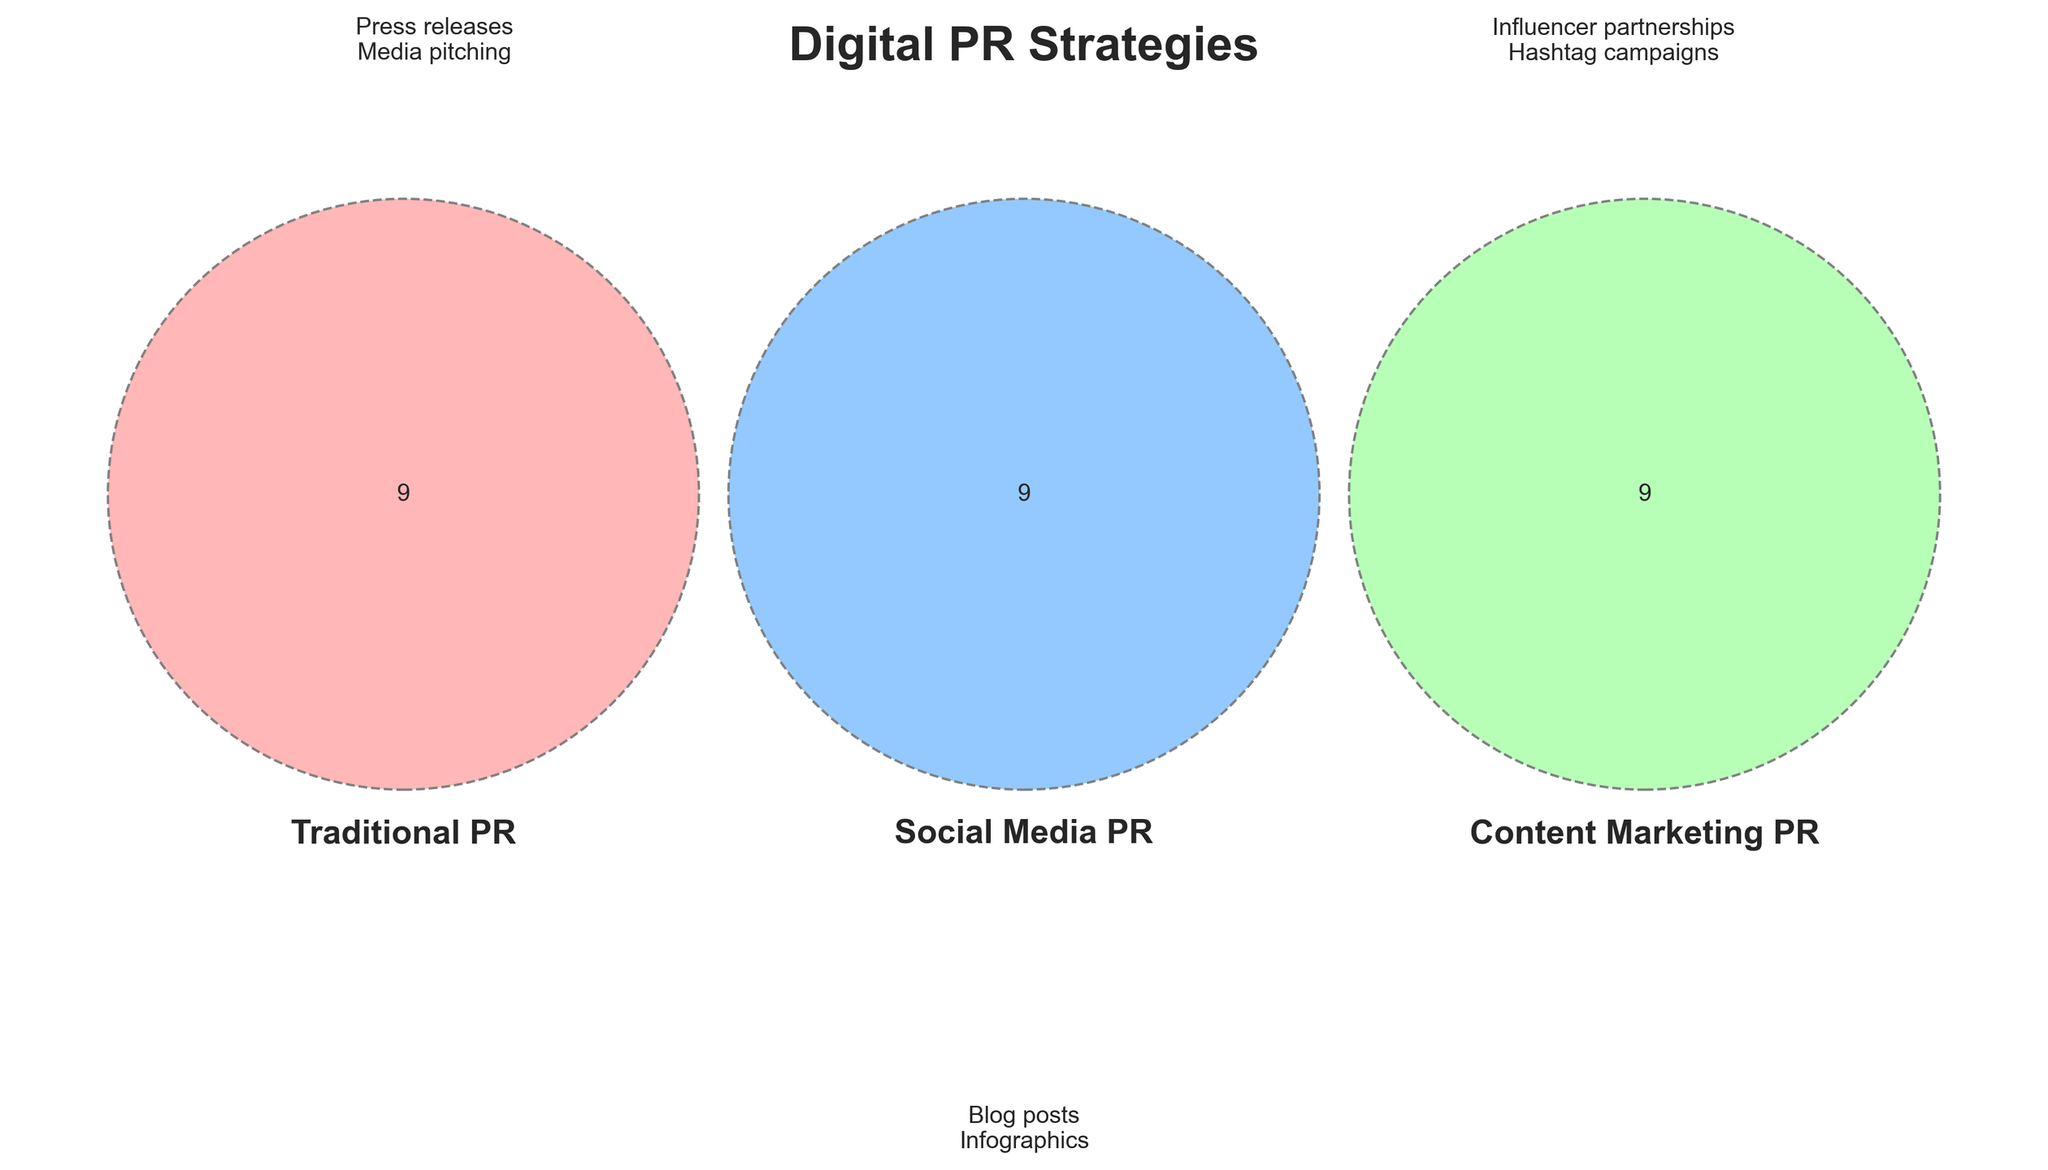What are the three types of PR strategies depicted in the Venn diagram? The Venn diagram shows three sets labeled 'Traditional PR', 'Social Media PR', and 'Content Marketing PR'. These are the three types of PR strategies indicated.
Answer: Traditional PR, Social Media PR, Content Marketing PR What is the title of the Venn diagram? The title of the Venn diagram is placed at the top of the figure and reads 'Digital PR Strategies'.
Answer: Digital PR Strategies What color represents 'Social Media PR'? In the Venn diagram, 'Social Media PR' is represented by the light blue color in the middle circle.
Answer: Light blue Name two strategies shared between 'Traditional PR' and 'Social Media PR'. The diagram shows overlapping sections where strategies shared between 'Traditional PR' and 'Social Media PR' are located. Examples provided include 'Press releases' and 'Media pitching'.
Answer: Press releases, Media pitching Which strategy is specific to 'Content Marketing PR' that is not shared with the other types? We can observe the unique area of the Venn diagram under 'Content Marketing PR'. Examples provided here include 'Blog posts' and 'Infographics'.
Answer: Blog posts, Infographics How many total strategies are listed in the 'Social Media PR' area? By counting the items in the 'Social Media PR' section of the Venn diagram, we determine there are nine strategies listed.
Answer: Nine What strategy is found at the intersection of all three PR types? The Venn diagram shows overlapping sections where all three sets intersect. There is no specific example given directly in the triple overlap area.
Answer: None Which PR strategy involves 'LinkedIn outreach' according to the Venn diagram? 'LinkedIn outreach' is listed within the 'Social Media PR' circle, as indicated by its mention in that section of the Venn diagram.
Answer: Social Media PR Which type of PR involves 'Video content' according to the diagram? 'Video content' is listed within the 'Content Marketing PR' circle, showing it pertains specifically to this PR type.
Answer: Content Marketing PR What are the circular dashed lines in the diagram meant to represent? The dashed circular lines in the Venn diagram visually distinguish the boundaries of each PR strategy set for clarity.
Answer: Boundaries of each PR set 